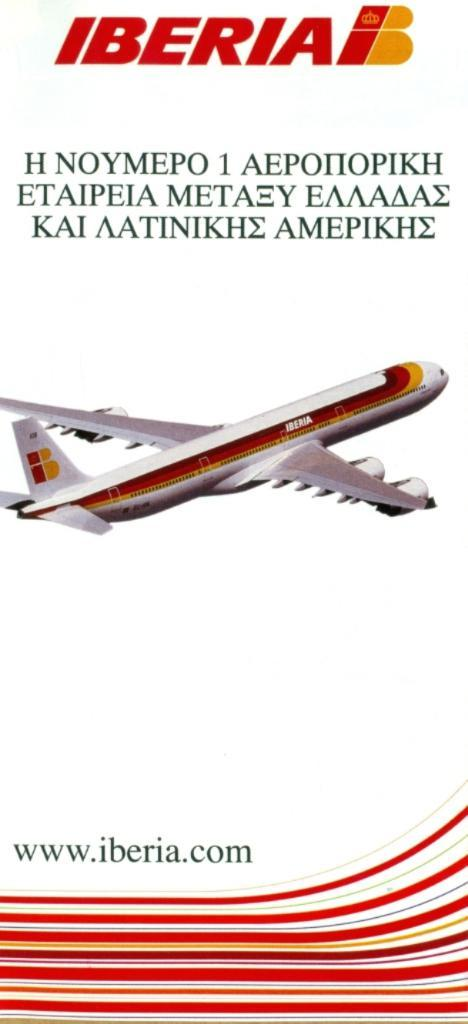What is the main subject of the poster in the image? The poster contains a picture of a plane. What else can be seen on the poster besides the picture of the plane? There is text on the poster. What color is the ink used for the text on the poster? There is no information about the color of the ink used for the text on the poster, as it is not mentioned in the provided facts. --- Facts: 1. There is a person sitting on a bench in the image. 2. The person is reading a book. 3. There is a tree behind the bench. 4. There is a fence in the image. 5. The ground is visible in the image. Absurd Topics: cat Conversation: What is the person in the image doing? The person in the image is reading a book. What can be seen behind the bench? There is a tree behind the bench. What other objects can be seen in the image? There is a fence in the image. What is visible on the ground in the image? The ground is visible in the image. Reasoning: Let's think step by step in order to produce the conversation. We start by identifying the main subject in the image, which is the person sitting on a bench. Next, we describe the action of the person, which is reading a book. Then, we observe the background of the image, noting the presence of a tree. After that, we identify other objects present in the image, such as a fence. Finally, we describe the ground visible in the image. Absurd Question/Answer: How many cats are visible on the person's lap in the image? There are no cats visible on the person's lap in the image. 